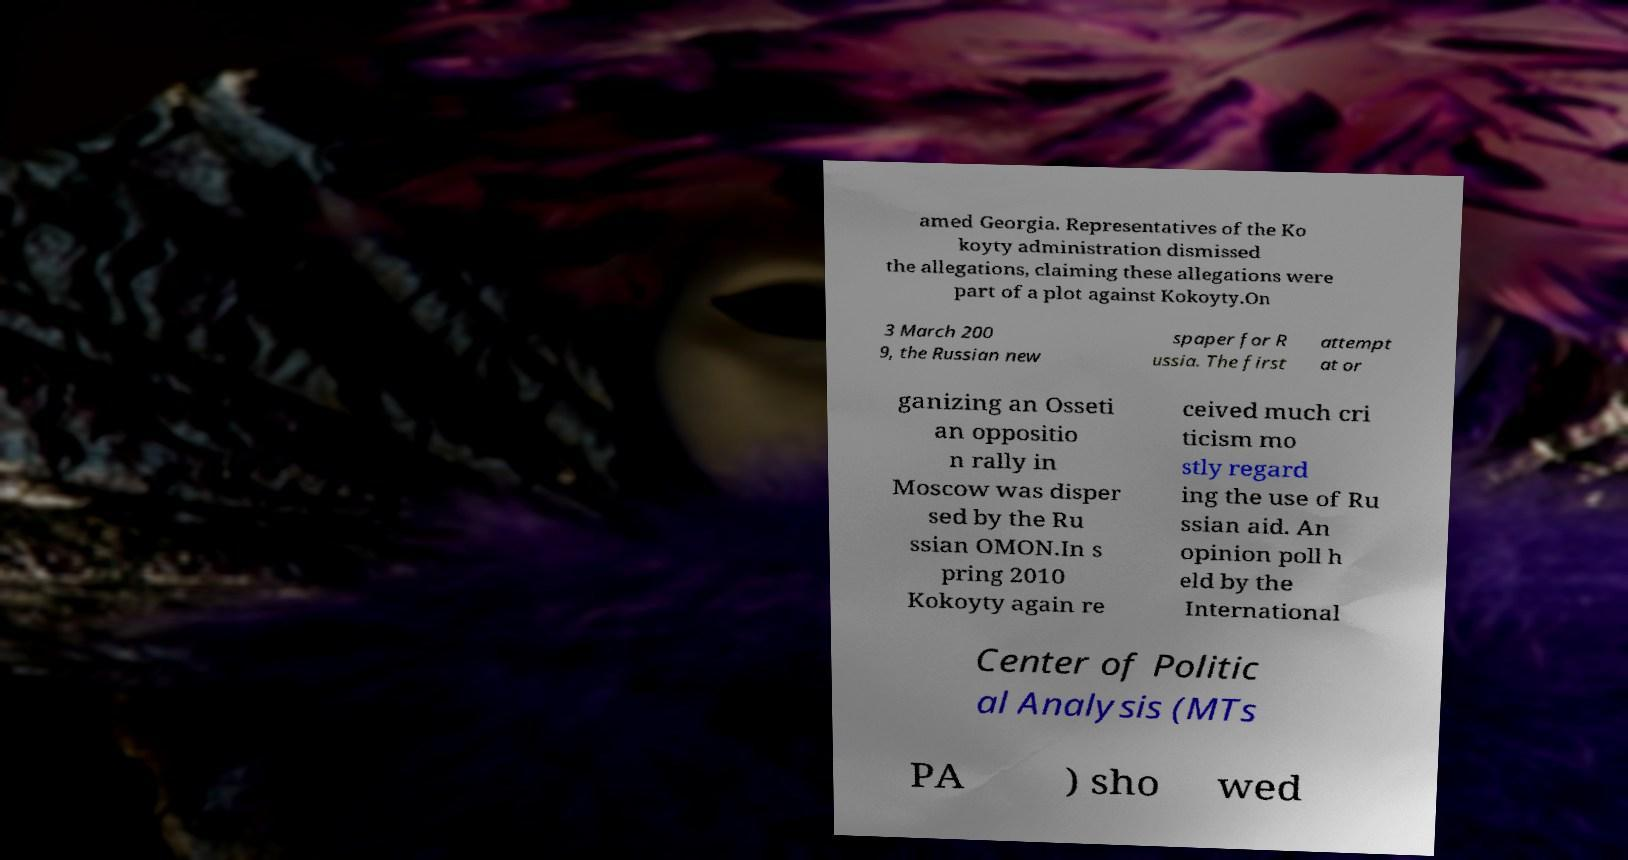Can you read and provide the text displayed in the image?This photo seems to have some interesting text. Can you extract and type it out for me? amed Georgia. Representatives of the Ko koyty administration dismissed the allegations, claiming these allegations were part of a plot against Kokoyty.On 3 March 200 9, the Russian new spaper for R ussia. The first attempt at or ganizing an Osseti an oppositio n rally in Moscow was disper sed by the Ru ssian OMON.In s pring 2010 Kokoyty again re ceived much cri ticism mo stly regard ing the use of Ru ssian aid. An opinion poll h eld by the International Center of Politic al Analysis (MTs PA ) sho wed 